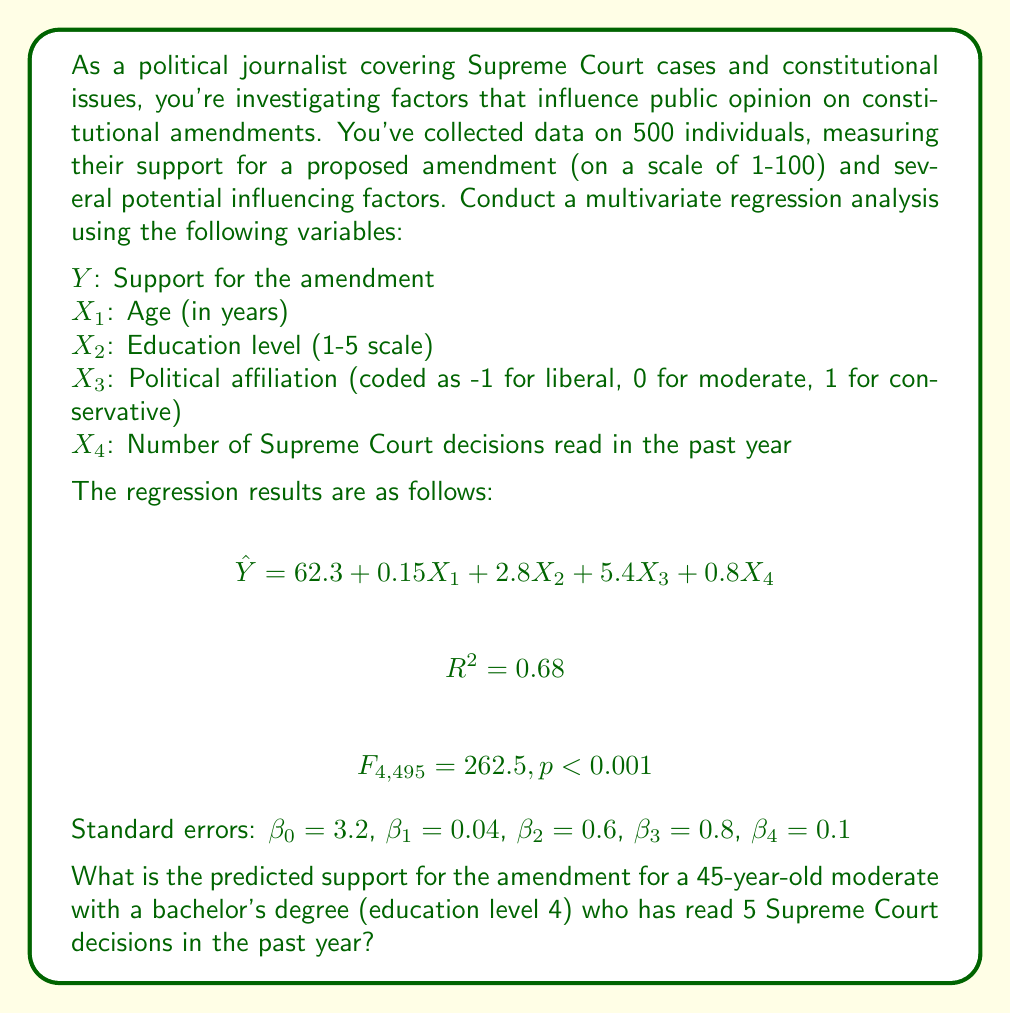Show me your answer to this math problem. To solve this problem, we need to use the multivariate regression equation provided and plug in the values for our hypothetical individual. Let's go through this step-by-step:

1. The regression equation is:
   $$\hat{Y} = 62.3 + 0.15X_1 + 2.8X_2 + 5.4X_3 + 0.8X_4$$

2. We need to substitute the values for each variable:
   $X_1$ (Age) = 45
   $X_2$ (Education level) = 4 (bachelor's degree)
   $X_3$ (Political affiliation) = 0 (moderate)
   $X_4$ (Number of Supreme Court decisions read) = 5

3. Let's plug these values into the equation:
   $$\hat{Y} = 62.3 + 0.15(45) + 2.8(4) + 5.4(0) + 0.8(5)$$

4. Now, let's calculate each term:
   $$\hat{Y} = 62.3 + 6.75 + 11.2 + 0 + 4$$

5. Finally, we sum up all the terms:
   $$\hat{Y} = 84.25$$

Therefore, the predicted support for the amendment for this individual is 84.25 on a scale of 1-100.

Note: The $R^2$ value of 0.68 indicates that about 68% of the variance in support for the amendment is explained by these four variables. The F-test result ($F_{4,495} = 262.5, p < 0.001$) suggests that the overall model is statistically significant.
Answer: 84.25 